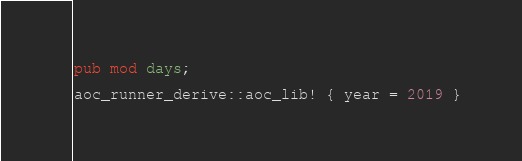<code> <loc_0><loc_0><loc_500><loc_500><_Rust_>pub mod days;

aoc_runner_derive::aoc_lib! { year = 2019 }
</code> 